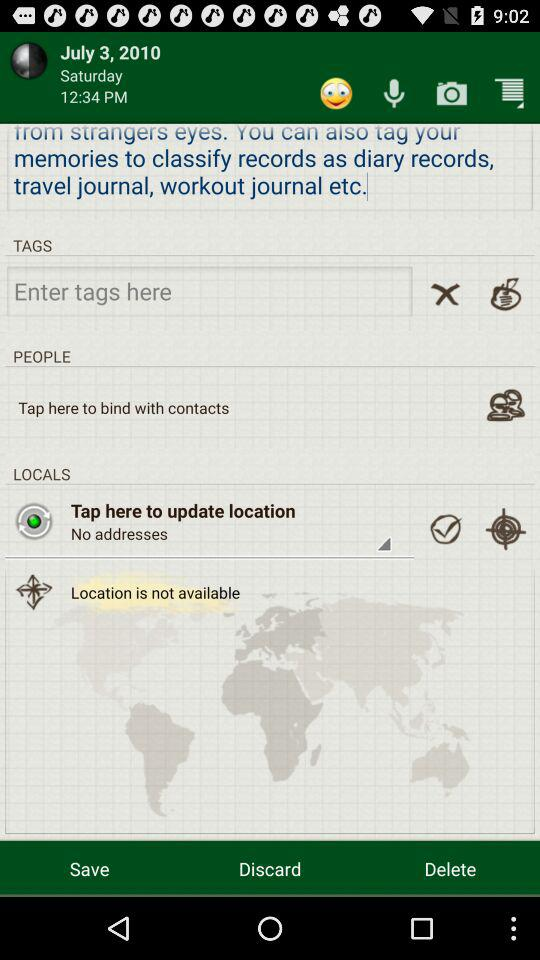What day is it on July 3, 2010? The day is Saturday. 